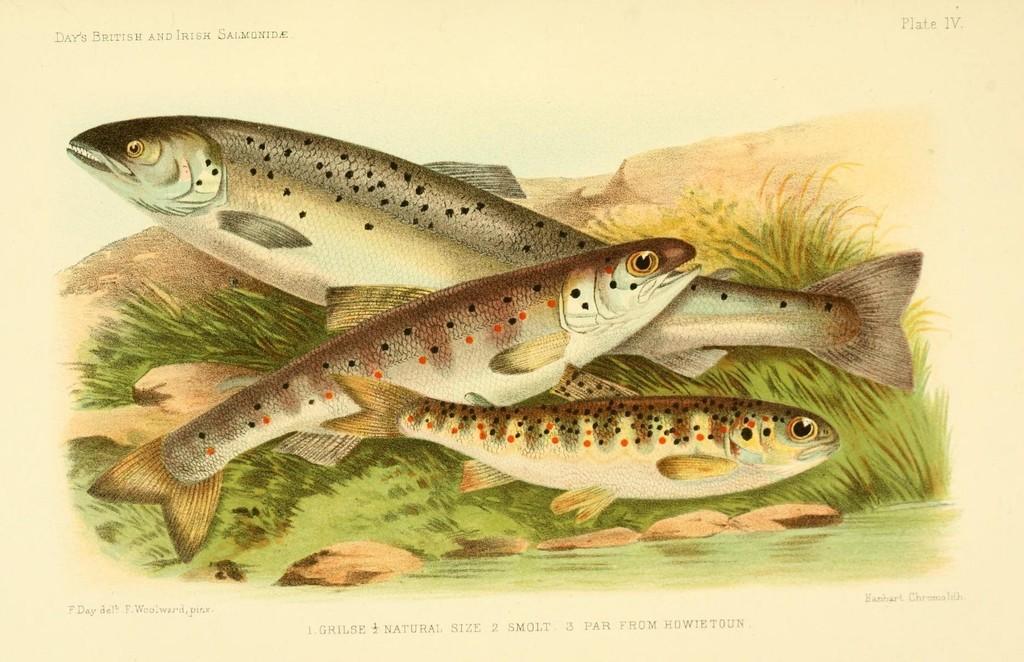Describe this image in one or two sentences. This picture is an art of paintings. In this picture, we see the fishes. At the bottom, we see grass. In the background, it is white in color. At the bottom of the picture, we see some text written on it. 